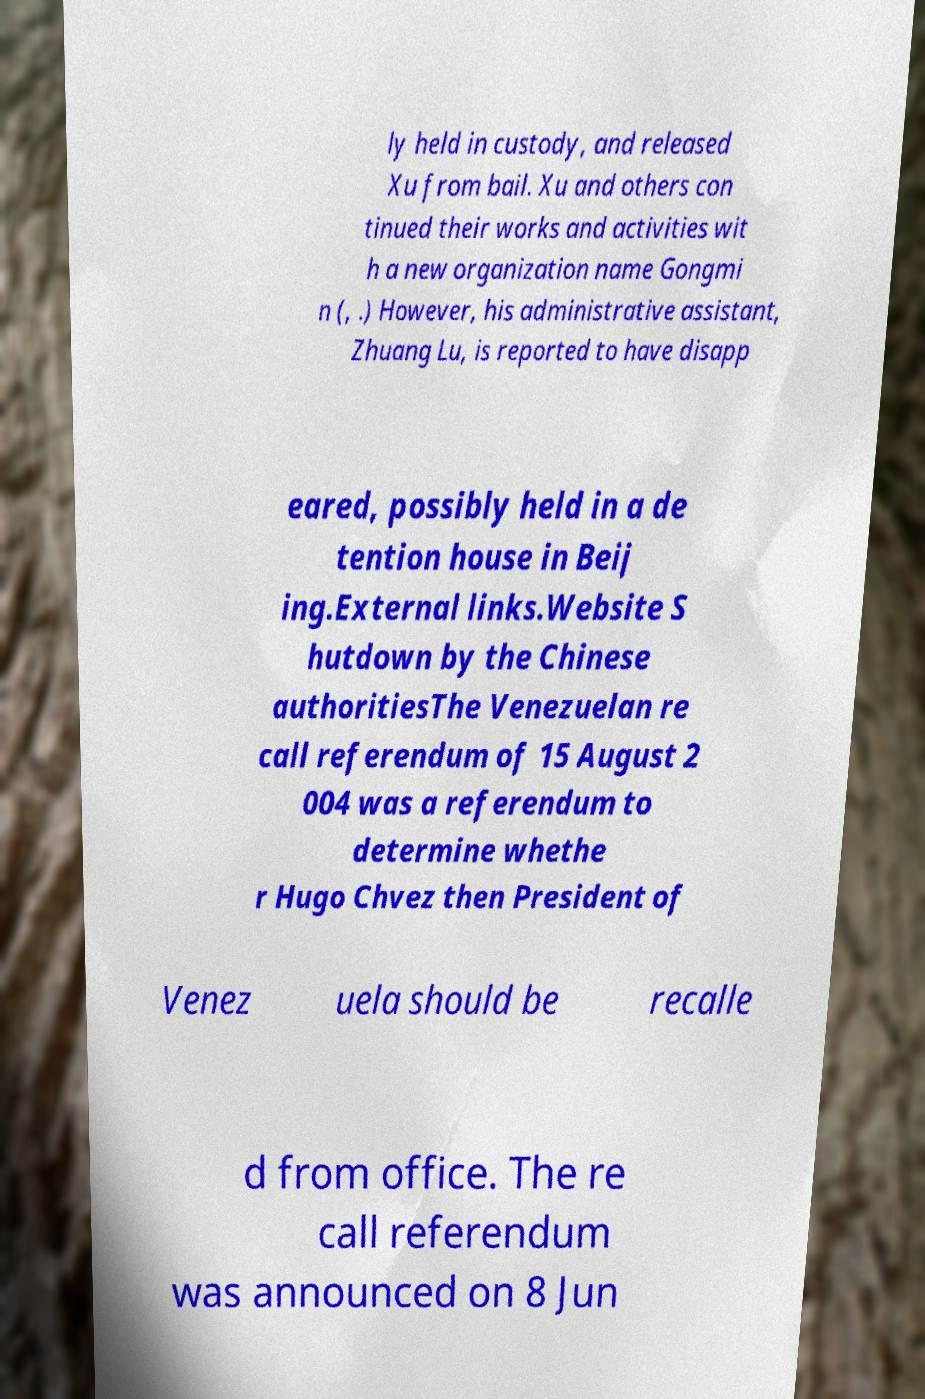There's text embedded in this image that I need extracted. Can you transcribe it verbatim? ly held in custody, and released Xu from bail. Xu and others con tinued their works and activities wit h a new organization name Gongmi n (, .) However, his administrative assistant, Zhuang Lu, is reported to have disapp eared, possibly held in a de tention house in Beij ing.External links.Website S hutdown by the Chinese authoritiesThe Venezuelan re call referendum of 15 August 2 004 was a referendum to determine whethe r Hugo Chvez then President of Venez uela should be recalle d from office. The re call referendum was announced on 8 Jun 